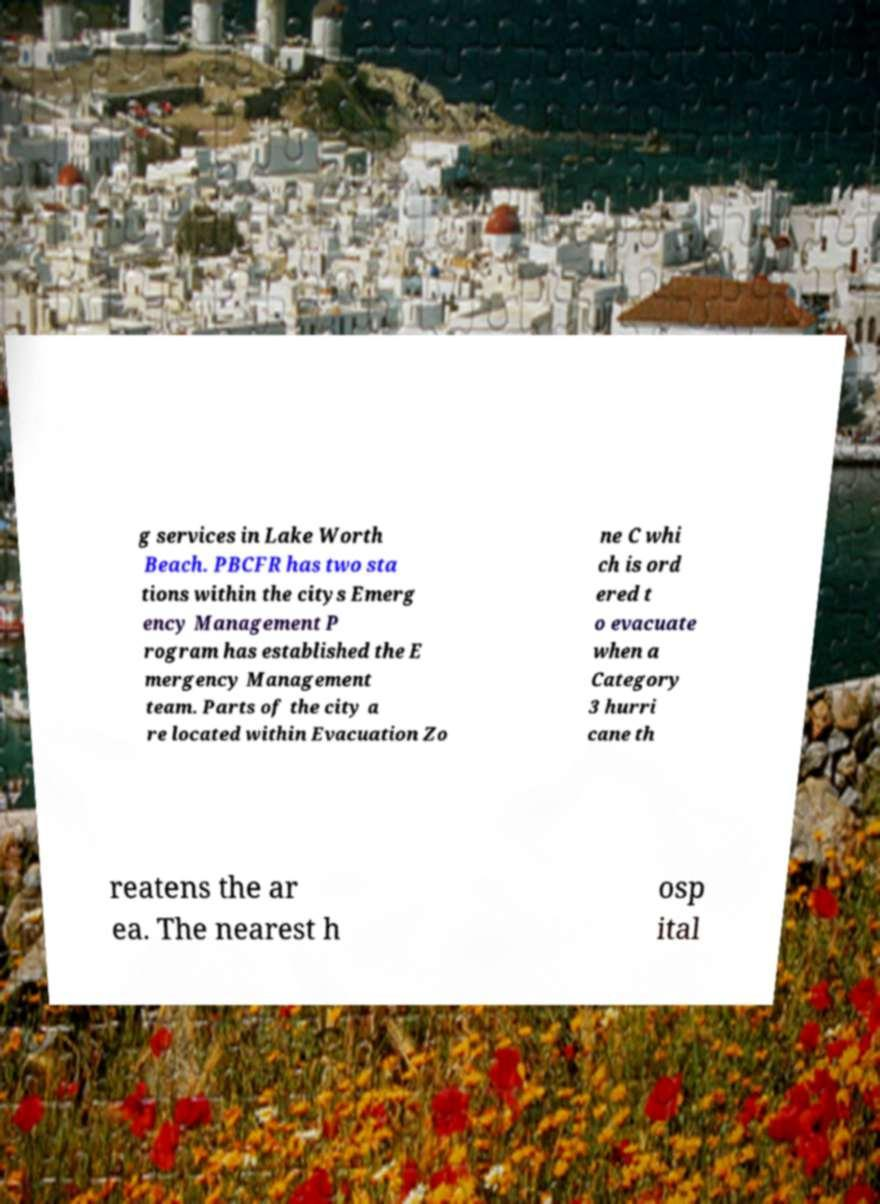Please identify and transcribe the text found in this image. g services in Lake Worth Beach. PBCFR has two sta tions within the citys Emerg ency Management P rogram has established the E mergency Management team. Parts of the city a re located within Evacuation Zo ne C whi ch is ord ered t o evacuate when a Category 3 hurri cane th reatens the ar ea. The nearest h osp ital 